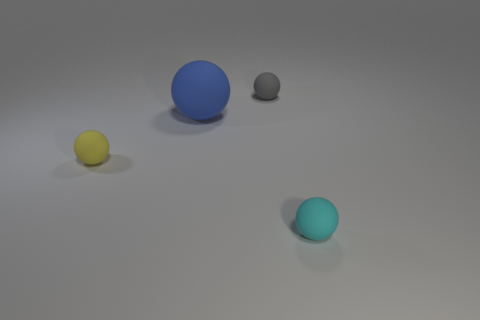Subtract all cyan spheres. How many spheres are left? 3 Add 1 big red metal cylinders. How many objects exist? 5 Subtract 1 spheres. How many spheres are left? 3 Subtract all blue spheres. How many spheres are left? 3 Add 1 cyan rubber cubes. How many cyan rubber cubes exist? 1 Subtract 0 red cylinders. How many objects are left? 4 Subtract all red balls. Subtract all blue cylinders. How many balls are left? 4 Subtract all gray blocks. How many gray spheres are left? 1 Subtract all big matte balls. Subtract all small balls. How many objects are left? 0 Add 1 tiny gray balls. How many tiny gray balls are left? 2 